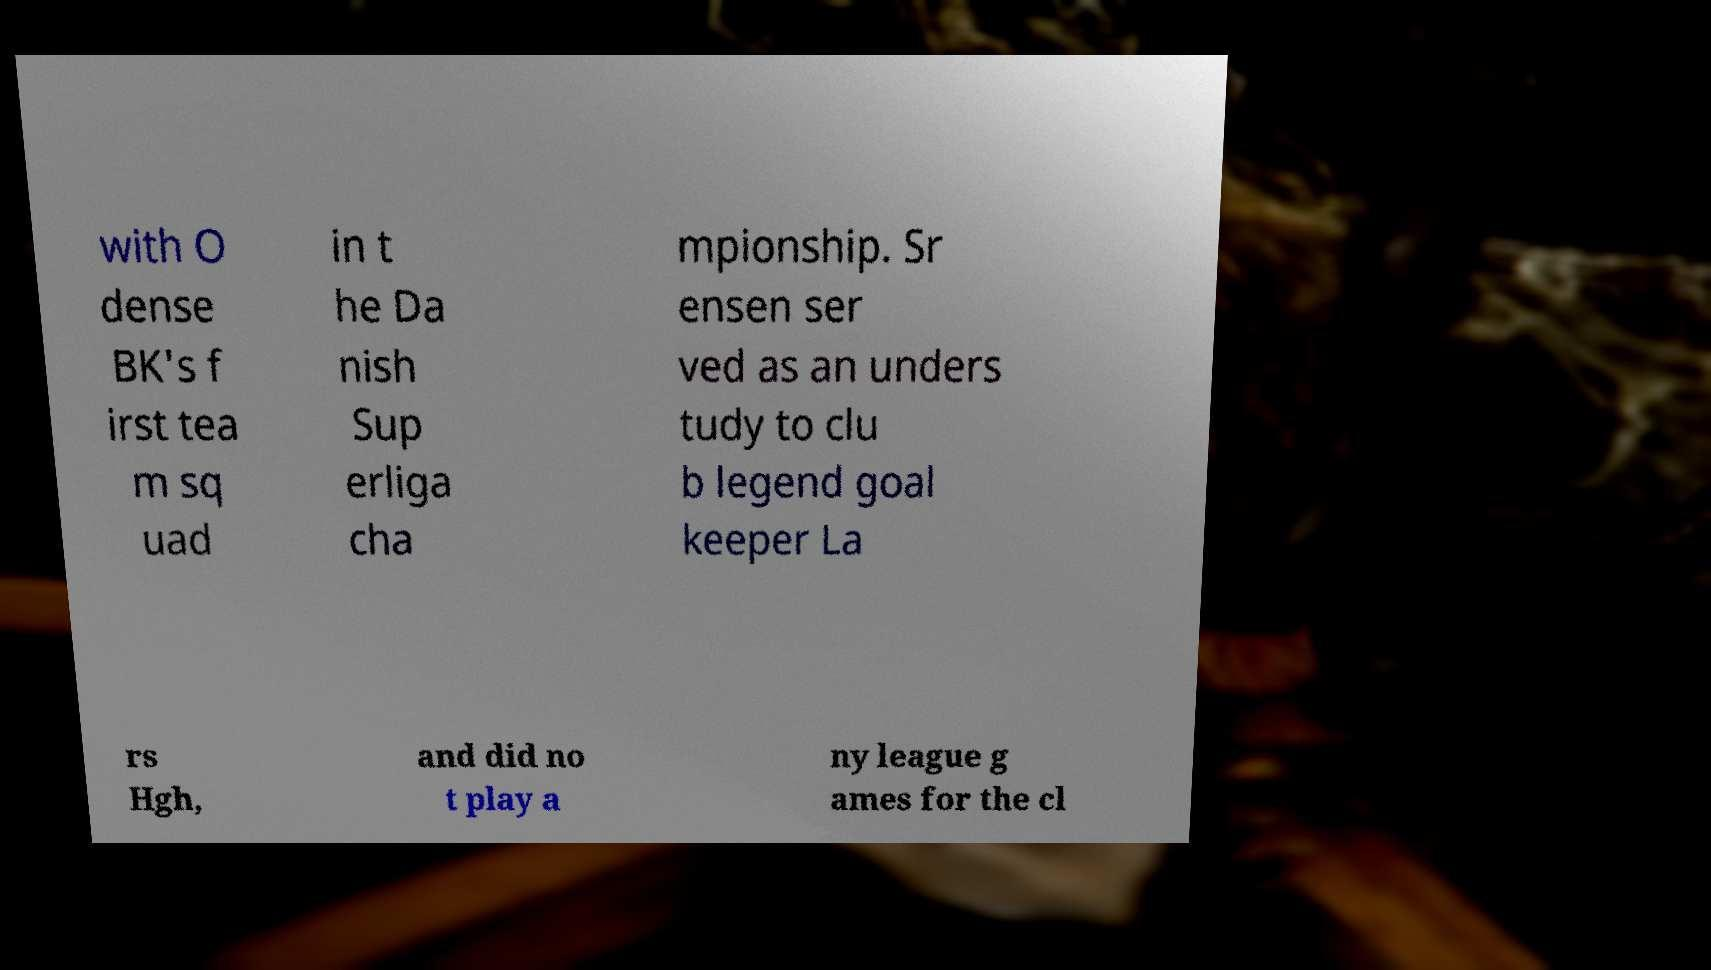For documentation purposes, I need the text within this image transcribed. Could you provide that? with O dense BK's f irst tea m sq uad in t he Da nish Sup erliga cha mpionship. Sr ensen ser ved as an unders tudy to clu b legend goal keeper La rs Hgh, and did no t play a ny league g ames for the cl 